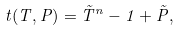<formula> <loc_0><loc_0><loc_500><loc_500>t ( T , P ) = \tilde { T } ^ { n } - 1 + \tilde { P } ,</formula> 